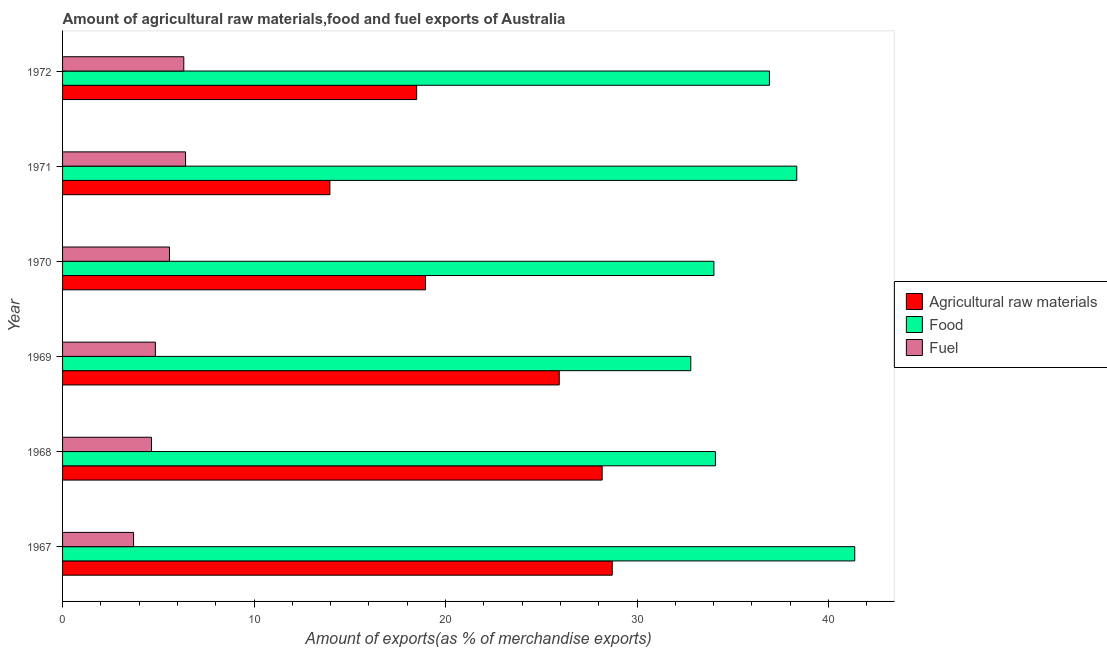Are the number of bars per tick equal to the number of legend labels?
Give a very brief answer. Yes. Are the number of bars on each tick of the Y-axis equal?
Keep it short and to the point. Yes. How many bars are there on the 1st tick from the top?
Offer a terse response. 3. What is the label of the 4th group of bars from the top?
Ensure brevity in your answer.  1969. What is the percentage of food exports in 1972?
Provide a succinct answer. 36.91. Across all years, what is the maximum percentage of food exports?
Give a very brief answer. 41.37. Across all years, what is the minimum percentage of fuel exports?
Provide a short and direct response. 3.71. In which year was the percentage of food exports maximum?
Give a very brief answer. 1967. In which year was the percentage of fuel exports minimum?
Your response must be concise. 1967. What is the total percentage of raw materials exports in the graph?
Your response must be concise. 134.22. What is the difference between the percentage of food exports in 1969 and that in 1971?
Provide a short and direct response. -5.53. What is the difference between the percentage of raw materials exports in 1971 and the percentage of fuel exports in 1968?
Offer a very short reply. 9.32. What is the average percentage of raw materials exports per year?
Keep it short and to the point. 22.37. In the year 1969, what is the difference between the percentage of fuel exports and percentage of food exports?
Keep it short and to the point. -27.96. In how many years, is the percentage of fuel exports greater than 28 %?
Give a very brief answer. 0. What is the ratio of the percentage of food exports in 1969 to that in 1971?
Offer a terse response. 0.86. Is the percentage of raw materials exports in 1967 less than that in 1969?
Make the answer very short. No. Is the difference between the percentage of raw materials exports in 1967 and 1969 greater than the difference between the percentage of food exports in 1967 and 1969?
Keep it short and to the point. No. What is the difference between the highest and the second highest percentage of raw materials exports?
Offer a very short reply. 0.53. What is the difference between the highest and the lowest percentage of fuel exports?
Give a very brief answer. 2.71. In how many years, is the percentage of food exports greater than the average percentage of food exports taken over all years?
Ensure brevity in your answer.  3. Is the sum of the percentage of food exports in 1970 and 1972 greater than the maximum percentage of raw materials exports across all years?
Your response must be concise. Yes. What does the 2nd bar from the top in 1969 represents?
Provide a short and direct response. Food. What does the 2nd bar from the bottom in 1972 represents?
Your response must be concise. Food. How many bars are there?
Ensure brevity in your answer.  18. What is the difference between two consecutive major ticks on the X-axis?
Provide a succinct answer. 10. Are the values on the major ticks of X-axis written in scientific E-notation?
Keep it short and to the point. No. Does the graph contain any zero values?
Offer a terse response. No. What is the title of the graph?
Offer a terse response. Amount of agricultural raw materials,food and fuel exports of Australia. What is the label or title of the X-axis?
Give a very brief answer. Amount of exports(as % of merchandise exports). What is the Amount of exports(as % of merchandise exports) of Agricultural raw materials in 1967?
Offer a terse response. 28.7. What is the Amount of exports(as % of merchandise exports) of Food in 1967?
Offer a terse response. 41.37. What is the Amount of exports(as % of merchandise exports) of Fuel in 1967?
Offer a terse response. 3.71. What is the Amount of exports(as % of merchandise exports) of Agricultural raw materials in 1968?
Your response must be concise. 28.18. What is the Amount of exports(as % of merchandise exports) of Food in 1968?
Your answer should be very brief. 34.09. What is the Amount of exports(as % of merchandise exports) in Fuel in 1968?
Provide a succinct answer. 4.64. What is the Amount of exports(as % of merchandise exports) of Agricultural raw materials in 1969?
Ensure brevity in your answer.  25.94. What is the Amount of exports(as % of merchandise exports) of Food in 1969?
Provide a succinct answer. 32.8. What is the Amount of exports(as % of merchandise exports) in Fuel in 1969?
Provide a succinct answer. 4.85. What is the Amount of exports(as % of merchandise exports) of Agricultural raw materials in 1970?
Offer a terse response. 18.95. What is the Amount of exports(as % of merchandise exports) in Food in 1970?
Your response must be concise. 34.01. What is the Amount of exports(as % of merchandise exports) in Fuel in 1970?
Make the answer very short. 5.58. What is the Amount of exports(as % of merchandise exports) of Agricultural raw materials in 1971?
Offer a very short reply. 13.96. What is the Amount of exports(as % of merchandise exports) of Food in 1971?
Ensure brevity in your answer.  38.34. What is the Amount of exports(as % of merchandise exports) of Fuel in 1971?
Offer a terse response. 6.42. What is the Amount of exports(as % of merchandise exports) of Agricultural raw materials in 1972?
Provide a short and direct response. 18.49. What is the Amount of exports(as % of merchandise exports) of Food in 1972?
Your answer should be compact. 36.91. What is the Amount of exports(as % of merchandise exports) of Fuel in 1972?
Your response must be concise. 6.33. Across all years, what is the maximum Amount of exports(as % of merchandise exports) of Agricultural raw materials?
Make the answer very short. 28.7. Across all years, what is the maximum Amount of exports(as % of merchandise exports) in Food?
Provide a succinct answer. 41.37. Across all years, what is the maximum Amount of exports(as % of merchandise exports) of Fuel?
Offer a terse response. 6.42. Across all years, what is the minimum Amount of exports(as % of merchandise exports) of Agricultural raw materials?
Offer a terse response. 13.96. Across all years, what is the minimum Amount of exports(as % of merchandise exports) of Food?
Offer a very short reply. 32.8. Across all years, what is the minimum Amount of exports(as % of merchandise exports) in Fuel?
Keep it short and to the point. 3.71. What is the total Amount of exports(as % of merchandise exports) of Agricultural raw materials in the graph?
Offer a terse response. 134.22. What is the total Amount of exports(as % of merchandise exports) of Food in the graph?
Offer a terse response. 217.53. What is the total Amount of exports(as % of merchandise exports) of Fuel in the graph?
Keep it short and to the point. 31.54. What is the difference between the Amount of exports(as % of merchandise exports) in Agricultural raw materials in 1967 and that in 1968?
Make the answer very short. 0.53. What is the difference between the Amount of exports(as % of merchandise exports) in Food in 1967 and that in 1968?
Your answer should be very brief. 7.27. What is the difference between the Amount of exports(as % of merchandise exports) in Fuel in 1967 and that in 1968?
Provide a short and direct response. -0.93. What is the difference between the Amount of exports(as % of merchandise exports) in Agricultural raw materials in 1967 and that in 1969?
Make the answer very short. 2.77. What is the difference between the Amount of exports(as % of merchandise exports) in Food in 1967 and that in 1969?
Your answer should be very brief. 8.56. What is the difference between the Amount of exports(as % of merchandise exports) of Fuel in 1967 and that in 1969?
Keep it short and to the point. -1.14. What is the difference between the Amount of exports(as % of merchandise exports) of Agricultural raw materials in 1967 and that in 1970?
Keep it short and to the point. 9.75. What is the difference between the Amount of exports(as % of merchandise exports) in Food in 1967 and that in 1970?
Keep it short and to the point. 7.35. What is the difference between the Amount of exports(as % of merchandise exports) in Fuel in 1967 and that in 1970?
Your response must be concise. -1.88. What is the difference between the Amount of exports(as % of merchandise exports) in Agricultural raw materials in 1967 and that in 1971?
Provide a short and direct response. 14.74. What is the difference between the Amount of exports(as % of merchandise exports) of Food in 1967 and that in 1971?
Offer a very short reply. 3.03. What is the difference between the Amount of exports(as % of merchandise exports) in Fuel in 1967 and that in 1971?
Offer a terse response. -2.71. What is the difference between the Amount of exports(as % of merchandise exports) of Agricultural raw materials in 1967 and that in 1972?
Give a very brief answer. 10.21. What is the difference between the Amount of exports(as % of merchandise exports) in Food in 1967 and that in 1972?
Offer a very short reply. 4.46. What is the difference between the Amount of exports(as % of merchandise exports) in Fuel in 1967 and that in 1972?
Ensure brevity in your answer.  -2.62. What is the difference between the Amount of exports(as % of merchandise exports) in Agricultural raw materials in 1968 and that in 1969?
Your answer should be compact. 2.24. What is the difference between the Amount of exports(as % of merchandise exports) in Food in 1968 and that in 1969?
Ensure brevity in your answer.  1.29. What is the difference between the Amount of exports(as % of merchandise exports) of Fuel in 1968 and that in 1969?
Offer a very short reply. -0.2. What is the difference between the Amount of exports(as % of merchandise exports) of Agricultural raw materials in 1968 and that in 1970?
Your answer should be compact. 9.22. What is the difference between the Amount of exports(as % of merchandise exports) of Food in 1968 and that in 1970?
Keep it short and to the point. 0.08. What is the difference between the Amount of exports(as % of merchandise exports) in Fuel in 1968 and that in 1970?
Keep it short and to the point. -0.94. What is the difference between the Amount of exports(as % of merchandise exports) in Agricultural raw materials in 1968 and that in 1971?
Provide a short and direct response. 14.22. What is the difference between the Amount of exports(as % of merchandise exports) of Food in 1968 and that in 1971?
Give a very brief answer. -4.25. What is the difference between the Amount of exports(as % of merchandise exports) of Fuel in 1968 and that in 1971?
Provide a short and direct response. -1.78. What is the difference between the Amount of exports(as % of merchandise exports) of Agricultural raw materials in 1968 and that in 1972?
Offer a very short reply. 9.69. What is the difference between the Amount of exports(as % of merchandise exports) of Food in 1968 and that in 1972?
Make the answer very short. -2.82. What is the difference between the Amount of exports(as % of merchandise exports) of Fuel in 1968 and that in 1972?
Offer a very short reply. -1.69. What is the difference between the Amount of exports(as % of merchandise exports) of Agricultural raw materials in 1969 and that in 1970?
Provide a short and direct response. 6.98. What is the difference between the Amount of exports(as % of merchandise exports) of Food in 1969 and that in 1970?
Your answer should be compact. -1.21. What is the difference between the Amount of exports(as % of merchandise exports) in Fuel in 1969 and that in 1970?
Offer a terse response. -0.74. What is the difference between the Amount of exports(as % of merchandise exports) of Agricultural raw materials in 1969 and that in 1971?
Your answer should be very brief. 11.98. What is the difference between the Amount of exports(as % of merchandise exports) of Food in 1969 and that in 1971?
Keep it short and to the point. -5.53. What is the difference between the Amount of exports(as % of merchandise exports) in Fuel in 1969 and that in 1971?
Offer a terse response. -1.58. What is the difference between the Amount of exports(as % of merchandise exports) in Agricultural raw materials in 1969 and that in 1972?
Your response must be concise. 7.45. What is the difference between the Amount of exports(as % of merchandise exports) of Food in 1969 and that in 1972?
Your answer should be very brief. -4.11. What is the difference between the Amount of exports(as % of merchandise exports) in Fuel in 1969 and that in 1972?
Offer a terse response. -1.48. What is the difference between the Amount of exports(as % of merchandise exports) in Agricultural raw materials in 1970 and that in 1971?
Ensure brevity in your answer.  4.99. What is the difference between the Amount of exports(as % of merchandise exports) of Food in 1970 and that in 1971?
Ensure brevity in your answer.  -4.33. What is the difference between the Amount of exports(as % of merchandise exports) of Fuel in 1970 and that in 1971?
Your answer should be very brief. -0.84. What is the difference between the Amount of exports(as % of merchandise exports) of Agricultural raw materials in 1970 and that in 1972?
Your response must be concise. 0.46. What is the difference between the Amount of exports(as % of merchandise exports) of Food in 1970 and that in 1972?
Provide a succinct answer. -2.9. What is the difference between the Amount of exports(as % of merchandise exports) of Fuel in 1970 and that in 1972?
Ensure brevity in your answer.  -0.75. What is the difference between the Amount of exports(as % of merchandise exports) of Agricultural raw materials in 1971 and that in 1972?
Make the answer very short. -4.53. What is the difference between the Amount of exports(as % of merchandise exports) of Food in 1971 and that in 1972?
Offer a terse response. 1.43. What is the difference between the Amount of exports(as % of merchandise exports) in Fuel in 1971 and that in 1972?
Your answer should be compact. 0.09. What is the difference between the Amount of exports(as % of merchandise exports) of Agricultural raw materials in 1967 and the Amount of exports(as % of merchandise exports) of Food in 1968?
Provide a succinct answer. -5.39. What is the difference between the Amount of exports(as % of merchandise exports) in Agricultural raw materials in 1967 and the Amount of exports(as % of merchandise exports) in Fuel in 1968?
Offer a very short reply. 24.06. What is the difference between the Amount of exports(as % of merchandise exports) of Food in 1967 and the Amount of exports(as % of merchandise exports) of Fuel in 1968?
Your answer should be compact. 36.72. What is the difference between the Amount of exports(as % of merchandise exports) in Agricultural raw materials in 1967 and the Amount of exports(as % of merchandise exports) in Food in 1969?
Make the answer very short. -4.1. What is the difference between the Amount of exports(as % of merchandise exports) of Agricultural raw materials in 1967 and the Amount of exports(as % of merchandise exports) of Fuel in 1969?
Provide a short and direct response. 23.86. What is the difference between the Amount of exports(as % of merchandise exports) in Food in 1967 and the Amount of exports(as % of merchandise exports) in Fuel in 1969?
Your answer should be very brief. 36.52. What is the difference between the Amount of exports(as % of merchandise exports) in Agricultural raw materials in 1967 and the Amount of exports(as % of merchandise exports) in Food in 1970?
Give a very brief answer. -5.31. What is the difference between the Amount of exports(as % of merchandise exports) of Agricultural raw materials in 1967 and the Amount of exports(as % of merchandise exports) of Fuel in 1970?
Offer a terse response. 23.12. What is the difference between the Amount of exports(as % of merchandise exports) in Food in 1967 and the Amount of exports(as % of merchandise exports) in Fuel in 1970?
Ensure brevity in your answer.  35.78. What is the difference between the Amount of exports(as % of merchandise exports) in Agricultural raw materials in 1967 and the Amount of exports(as % of merchandise exports) in Food in 1971?
Give a very brief answer. -9.64. What is the difference between the Amount of exports(as % of merchandise exports) in Agricultural raw materials in 1967 and the Amount of exports(as % of merchandise exports) in Fuel in 1971?
Provide a short and direct response. 22.28. What is the difference between the Amount of exports(as % of merchandise exports) in Food in 1967 and the Amount of exports(as % of merchandise exports) in Fuel in 1971?
Your response must be concise. 34.94. What is the difference between the Amount of exports(as % of merchandise exports) in Agricultural raw materials in 1967 and the Amount of exports(as % of merchandise exports) in Food in 1972?
Offer a terse response. -8.21. What is the difference between the Amount of exports(as % of merchandise exports) of Agricultural raw materials in 1967 and the Amount of exports(as % of merchandise exports) of Fuel in 1972?
Keep it short and to the point. 22.37. What is the difference between the Amount of exports(as % of merchandise exports) in Food in 1967 and the Amount of exports(as % of merchandise exports) in Fuel in 1972?
Your answer should be very brief. 35.04. What is the difference between the Amount of exports(as % of merchandise exports) in Agricultural raw materials in 1968 and the Amount of exports(as % of merchandise exports) in Food in 1969?
Provide a short and direct response. -4.63. What is the difference between the Amount of exports(as % of merchandise exports) in Agricultural raw materials in 1968 and the Amount of exports(as % of merchandise exports) in Fuel in 1969?
Provide a succinct answer. 23.33. What is the difference between the Amount of exports(as % of merchandise exports) in Food in 1968 and the Amount of exports(as % of merchandise exports) in Fuel in 1969?
Keep it short and to the point. 29.25. What is the difference between the Amount of exports(as % of merchandise exports) of Agricultural raw materials in 1968 and the Amount of exports(as % of merchandise exports) of Food in 1970?
Offer a terse response. -5.84. What is the difference between the Amount of exports(as % of merchandise exports) of Agricultural raw materials in 1968 and the Amount of exports(as % of merchandise exports) of Fuel in 1970?
Keep it short and to the point. 22.59. What is the difference between the Amount of exports(as % of merchandise exports) of Food in 1968 and the Amount of exports(as % of merchandise exports) of Fuel in 1970?
Provide a succinct answer. 28.51. What is the difference between the Amount of exports(as % of merchandise exports) in Agricultural raw materials in 1968 and the Amount of exports(as % of merchandise exports) in Food in 1971?
Make the answer very short. -10.16. What is the difference between the Amount of exports(as % of merchandise exports) in Agricultural raw materials in 1968 and the Amount of exports(as % of merchandise exports) in Fuel in 1971?
Keep it short and to the point. 21.75. What is the difference between the Amount of exports(as % of merchandise exports) of Food in 1968 and the Amount of exports(as % of merchandise exports) of Fuel in 1971?
Provide a short and direct response. 27.67. What is the difference between the Amount of exports(as % of merchandise exports) of Agricultural raw materials in 1968 and the Amount of exports(as % of merchandise exports) of Food in 1972?
Provide a short and direct response. -8.73. What is the difference between the Amount of exports(as % of merchandise exports) of Agricultural raw materials in 1968 and the Amount of exports(as % of merchandise exports) of Fuel in 1972?
Make the answer very short. 21.85. What is the difference between the Amount of exports(as % of merchandise exports) in Food in 1968 and the Amount of exports(as % of merchandise exports) in Fuel in 1972?
Make the answer very short. 27.76. What is the difference between the Amount of exports(as % of merchandise exports) in Agricultural raw materials in 1969 and the Amount of exports(as % of merchandise exports) in Food in 1970?
Provide a succinct answer. -8.08. What is the difference between the Amount of exports(as % of merchandise exports) in Agricultural raw materials in 1969 and the Amount of exports(as % of merchandise exports) in Fuel in 1970?
Ensure brevity in your answer.  20.35. What is the difference between the Amount of exports(as % of merchandise exports) of Food in 1969 and the Amount of exports(as % of merchandise exports) of Fuel in 1970?
Make the answer very short. 27.22. What is the difference between the Amount of exports(as % of merchandise exports) of Agricultural raw materials in 1969 and the Amount of exports(as % of merchandise exports) of Food in 1971?
Provide a succinct answer. -12.4. What is the difference between the Amount of exports(as % of merchandise exports) in Agricultural raw materials in 1969 and the Amount of exports(as % of merchandise exports) in Fuel in 1971?
Make the answer very short. 19.51. What is the difference between the Amount of exports(as % of merchandise exports) of Food in 1969 and the Amount of exports(as % of merchandise exports) of Fuel in 1971?
Your answer should be compact. 26.38. What is the difference between the Amount of exports(as % of merchandise exports) in Agricultural raw materials in 1969 and the Amount of exports(as % of merchandise exports) in Food in 1972?
Provide a short and direct response. -10.97. What is the difference between the Amount of exports(as % of merchandise exports) in Agricultural raw materials in 1969 and the Amount of exports(as % of merchandise exports) in Fuel in 1972?
Your answer should be very brief. 19.61. What is the difference between the Amount of exports(as % of merchandise exports) of Food in 1969 and the Amount of exports(as % of merchandise exports) of Fuel in 1972?
Make the answer very short. 26.47. What is the difference between the Amount of exports(as % of merchandise exports) in Agricultural raw materials in 1970 and the Amount of exports(as % of merchandise exports) in Food in 1971?
Your answer should be very brief. -19.38. What is the difference between the Amount of exports(as % of merchandise exports) in Agricultural raw materials in 1970 and the Amount of exports(as % of merchandise exports) in Fuel in 1971?
Make the answer very short. 12.53. What is the difference between the Amount of exports(as % of merchandise exports) in Food in 1970 and the Amount of exports(as % of merchandise exports) in Fuel in 1971?
Your response must be concise. 27.59. What is the difference between the Amount of exports(as % of merchandise exports) in Agricultural raw materials in 1970 and the Amount of exports(as % of merchandise exports) in Food in 1972?
Make the answer very short. -17.96. What is the difference between the Amount of exports(as % of merchandise exports) in Agricultural raw materials in 1970 and the Amount of exports(as % of merchandise exports) in Fuel in 1972?
Ensure brevity in your answer.  12.62. What is the difference between the Amount of exports(as % of merchandise exports) in Food in 1970 and the Amount of exports(as % of merchandise exports) in Fuel in 1972?
Keep it short and to the point. 27.68. What is the difference between the Amount of exports(as % of merchandise exports) of Agricultural raw materials in 1971 and the Amount of exports(as % of merchandise exports) of Food in 1972?
Make the answer very short. -22.95. What is the difference between the Amount of exports(as % of merchandise exports) in Agricultural raw materials in 1971 and the Amount of exports(as % of merchandise exports) in Fuel in 1972?
Your answer should be compact. 7.63. What is the difference between the Amount of exports(as % of merchandise exports) of Food in 1971 and the Amount of exports(as % of merchandise exports) of Fuel in 1972?
Keep it short and to the point. 32.01. What is the average Amount of exports(as % of merchandise exports) in Agricultural raw materials per year?
Make the answer very short. 22.37. What is the average Amount of exports(as % of merchandise exports) in Food per year?
Your response must be concise. 36.25. What is the average Amount of exports(as % of merchandise exports) of Fuel per year?
Your answer should be very brief. 5.26. In the year 1967, what is the difference between the Amount of exports(as % of merchandise exports) in Agricultural raw materials and Amount of exports(as % of merchandise exports) in Food?
Offer a terse response. -12.66. In the year 1967, what is the difference between the Amount of exports(as % of merchandise exports) of Agricultural raw materials and Amount of exports(as % of merchandise exports) of Fuel?
Offer a very short reply. 25. In the year 1967, what is the difference between the Amount of exports(as % of merchandise exports) of Food and Amount of exports(as % of merchandise exports) of Fuel?
Ensure brevity in your answer.  37.66. In the year 1968, what is the difference between the Amount of exports(as % of merchandise exports) in Agricultural raw materials and Amount of exports(as % of merchandise exports) in Food?
Your response must be concise. -5.92. In the year 1968, what is the difference between the Amount of exports(as % of merchandise exports) of Agricultural raw materials and Amount of exports(as % of merchandise exports) of Fuel?
Provide a short and direct response. 23.53. In the year 1968, what is the difference between the Amount of exports(as % of merchandise exports) of Food and Amount of exports(as % of merchandise exports) of Fuel?
Ensure brevity in your answer.  29.45. In the year 1969, what is the difference between the Amount of exports(as % of merchandise exports) in Agricultural raw materials and Amount of exports(as % of merchandise exports) in Food?
Your answer should be very brief. -6.87. In the year 1969, what is the difference between the Amount of exports(as % of merchandise exports) of Agricultural raw materials and Amount of exports(as % of merchandise exports) of Fuel?
Keep it short and to the point. 21.09. In the year 1969, what is the difference between the Amount of exports(as % of merchandise exports) in Food and Amount of exports(as % of merchandise exports) in Fuel?
Offer a terse response. 27.96. In the year 1970, what is the difference between the Amount of exports(as % of merchandise exports) of Agricultural raw materials and Amount of exports(as % of merchandise exports) of Food?
Offer a very short reply. -15.06. In the year 1970, what is the difference between the Amount of exports(as % of merchandise exports) in Agricultural raw materials and Amount of exports(as % of merchandise exports) in Fuel?
Offer a very short reply. 13.37. In the year 1970, what is the difference between the Amount of exports(as % of merchandise exports) in Food and Amount of exports(as % of merchandise exports) in Fuel?
Your answer should be very brief. 28.43. In the year 1971, what is the difference between the Amount of exports(as % of merchandise exports) in Agricultural raw materials and Amount of exports(as % of merchandise exports) in Food?
Your answer should be compact. -24.38. In the year 1971, what is the difference between the Amount of exports(as % of merchandise exports) of Agricultural raw materials and Amount of exports(as % of merchandise exports) of Fuel?
Provide a succinct answer. 7.54. In the year 1971, what is the difference between the Amount of exports(as % of merchandise exports) in Food and Amount of exports(as % of merchandise exports) in Fuel?
Give a very brief answer. 31.92. In the year 1972, what is the difference between the Amount of exports(as % of merchandise exports) in Agricultural raw materials and Amount of exports(as % of merchandise exports) in Food?
Your answer should be compact. -18.42. In the year 1972, what is the difference between the Amount of exports(as % of merchandise exports) in Agricultural raw materials and Amount of exports(as % of merchandise exports) in Fuel?
Your answer should be very brief. 12.16. In the year 1972, what is the difference between the Amount of exports(as % of merchandise exports) in Food and Amount of exports(as % of merchandise exports) in Fuel?
Keep it short and to the point. 30.58. What is the ratio of the Amount of exports(as % of merchandise exports) in Agricultural raw materials in 1967 to that in 1968?
Provide a short and direct response. 1.02. What is the ratio of the Amount of exports(as % of merchandise exports) in Food in 1967 to that in 1968?
Provide a short and direct response. 1.21. What is the ratio of the Amount of exports(as % of merchandise exports) in Fuel in 1967 to that in 1968?
Provide a succinct answer. 0.8. What is the ratio of the Amount of exports(as % of merchandise exports) in Agricultural raw materials in 1967 to that in 1969?
Offer a terse response. 1.11. What is the ratio of the Amount of exports(as % of merchandise exports) of Food in 1967 to that in 1969?
Offer a terse response. 1.26. What is the ratio of the Amount of exports(as % of merchandise exports) in Fuel in 1967 to that in 1969?
Give a very brief answer. 0.77. What is the ratio of the Amount of exports(as % of merchandise exports) of Agricultural raw materials in 1967 to that in 1970?
Make the answer very short. 1.51. What is the ratio of the Amount of exports(as % of merchandise exports) of Food in 1967 to that in 1970?
Give a very brief answer. 1.22. What is the ratio of the Amount of exports(as % of merchandise exports) of Fuel in 1967 to that in 1970?
Keep it short and to the point. 0.66. What is the ratio of the Amount of exports(as % of merchandise exports) in Agricultural raw materials in 1967 to that in 1971?
Give a very brief answer. 2.06. What is the ratio of the Amount of exports(as % of merchandise exports) of Food in 1967 to that in 1971?
Your response must be concise. 1.08. What is the ratio of the Amount of exports(as % of merchandise exports) of Fuel in 1967 to that in 1971?
Keep it short and to the point. 0.58. What is the ratio of the Amount of exports(as % of merchandise exports) of Agricultural raw materials in 1967 to that in 1972?
Offer a very short reply. 1.55. What is the ratio of the Amount of exports(as % of merchandise exports) in Food in 1967 to that in 1972?
Ensure brevity in your answer.  1.12. What is the ratio of the Amount of exports(as % of merchandise exports) in Fuel in 1967 to that in 1972?
Your response must be concise. 0.59. What is the ratio of the Amount of exports(as % of merchandise exports) in Agricultural raw materials in 1968 to that in 1969?
Your answer should be compact. 1.09. What is the ratio of the Amount of exports(as % of merchandise exports) of Food in 1968 to that in 1969?
Make the answer very short. 1.04. What is the ratio of the Amount of exports(as % of merchandise exports) in Fuel in 1968 to that in 1969?
Make the answer very short. 0.96. What is the ratio of the Amount of exports(as % of merchandise exports) in Agricultural raw materials in 1968 to that in 1970?
Ensure brevity in your answer.  1.49. What is the ratio of the Amount of exports(as % of merchandise exports) in Fuel in 1968 to that in 1970?
Provide a succinct answer. 0.83. What is the ratio of the Amount of exports(as % of merchandise exports) in Agricultural raw materials in 1968 to that in 1971?
Provide a succinct answer. 2.02. What is the ratio of the Amount of exports(as % of merchandise exports) of Food in 1968 to that in 1971?
Ensure brevity in your answer.  0.89. What is the ratio of the Amount of exports(as % of merchandise exports) of Fuel in 1968 to that in 1971?
Make the answer very short. 0.72. What is the ratio of the Amount of exports(as % of merchandise exports) in Agricultural raw materials in 1968 to that in 1972?
Give a very brief answer. 1.52. What is the ratio of the Amount of exports(as % of merchandise exports) in Food in 1968 to that in 1972?
Provide a short and direct response. 0.92. What is the ratio of the Amount of exports(as % of merchandise exports) in Fuel in 1968 to that in 1972?
Make the answer very short. 0.73. What is the ratio of the Amount of exports(as % of merchandise exports) in Agricultural raw materials in 1969 to that in 1970?
Give a very brief answer. 1.37. What is the ratio of the Amount of exports(as % of merchandise exports) in Food in 1969 to that in 1970?
Offer a very short reply. 0.96. What is the ratio of the Amount of exports(as % of merchandise exports) of Fuel in 1969 to that in 1970?
Ensure brevity in your answer.  0.87. What is the ratio of the Amount of exports(as % of merchandise exports) of Agricultural raw materials in 1969 to that in 1971?
Make the answer very short. 1.86. What is the ratio of the Amount of exports(as % of merchandise exports) of Food in 1969 to that in 1971?
Make the answer very short. 0.86. What is the ratio of the Amount of exports(as % of merchandise exports) of Fuel in 1969 to that in 1971?
Offer a very short reply. 0.75. What is the ratio of the Amount of exports(as % of merchandise exports) of Agricultural raw materials in 1969 to that in 1972?
Offer a very short reply. 1.4. What is the ratio of the Amount of exports(as % of merchandise exports) of Food in 1969 to that in 1972?
Your response must be concise. 0.89. What is the ratio of the Amount of exports(as % of merchandise exports) in Fuel in 1969 to that in 1972?
Ensure brevity in your answer.  0.77. What is the ratio of the Amount of exports(as % of merchandise exports) in Agricultural raw materials in 1970 to that in 1971?
Offer a very short reply. 1.36. What is the ratio of the Amount of exports(as % of merchandise exports) in Food in 1970 to that in 1971?
Give a very brief answer. 0.89. What is the ratio of the Amount of exports(as % of merchandise exports) of Fuel in 1970 to that in 1971?
Keep it short and to the point. 0.87. What is the ratio of the Amount of exports(as % of merchandise exports) of Agricultural raw materials in 1970 to that in 1972?
Keep it short and to the point. 1.03. What is the ratio of the Amount of exports(as % of merchandise exports) of Food in 1970 to that in 1972?
Keep it short and to the point. 0.92. What is the ratio of the Amount of exports(as % of merchandise exports) in Fuel in 1970 to that in 1972?
Offer a terse response. 0.88. What is the ratio of the Amount of exports(as % of merchandise exports) in Agricultural raw materials in 1971 to that in 1972?
Provide a short and direct response. 0.76. What is the ratio of the Amount of exports(as % of merchandise exports) in Food in 1971 to that in 1972?
Provide a succinct answer. 1.04. What is the ratio of the Amount of exports(as % of merchandise exports) in Fuel in 1971 to that in 1972?
Keep it short and to the point. 1.01. What is the difference between the highest and the second highest Amount of exports(as % of merchandise exports) of Agricultural raw materials?
Make the answer very short. 0.53. What is the difference between the highest and the second highest Amount of exports(as % of merchandise exports) of Food?
Your answer should be compact. 3.03. What is the difference between the highest and the second highest Amount of exports(as % of merchandise exports) in Fuel?
Your answer should be compact. 0.09. What is the difference between the highest and the lowest Amount of exports(as % of merchandise exports) of Agricultural raw materials?
Your response must be concise. 14.74. What is the difference between the highest and the lowest Amount of exports(as % of merchandise exports) in Food?
Give a very brief answer. 8.56. What is the difference between the highest and the lowest Amount of exports(as % of merchandise exports) of Fuel?
Ensure brevity in your answer.  2.71. 